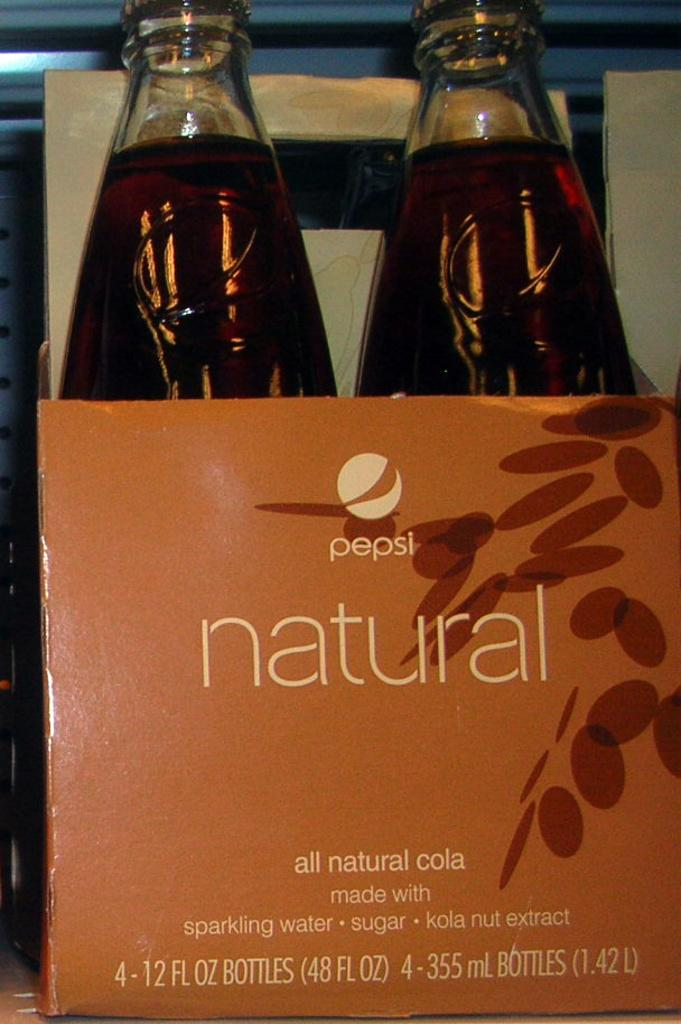<image>
Render a clear and concise summary of the photo. A box of natural pepsi made with sparkling water, sugar and kola nut extract. 